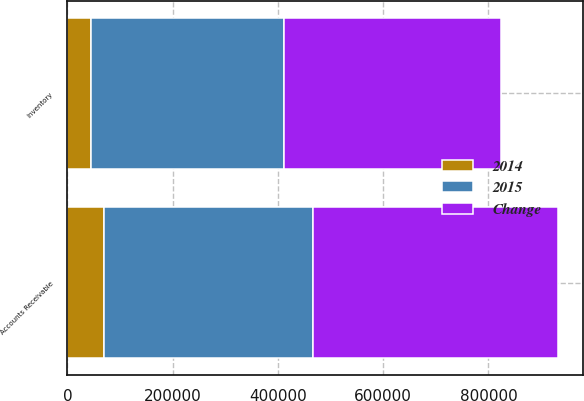Convert chart. <chart><loc_0><loc_0><loc_500><loc_500><stacked_bar_chart><ecel><fcel>Accounts Receivable<fcel>Inventory<nl><fcel>Change<fcel>466527<fcel>412314<nl><fcel>2015<fcel>396605<fcel>367927<nl><fcel>2014<fcel>69922<fcel>44387<nl></chart> 